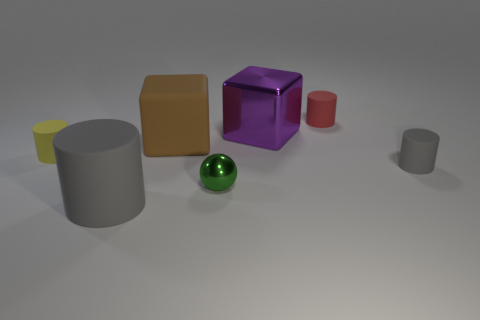Is the number of cylinders in front of the big purple block less than the number of things that are behind the small gray rubber cylinder?
Your response must be concise. Yes. There is a metallic thing that is in front of the gray object right of the large cylinder; what is its shape?
Offer a very short reply. Sphere. Are there any big balls?
Offer a very short reply. No. The metallic thing right of the green ball is what color?
Keep it short and to the point. Purple. What is the material of the other cylinder that is the same color as the large rubber cylinder?
Ensure brevity in your answer.  Rubber. Are there any red matte things on the right side of the tiny gray cylinder?
Keep it short and to the point. No. Are there more yellow cylinders than cyan blocks?
Keep it short and to the point. Yes. What color is the rubber thing on the right side of the small rubber cylinder that is behind the tiny rubber cylinder that is to the left of the metal sphere?
Provide a short and direct response. Gray. There is a block that is made of the same material as the big gray cylinder; what is its color?
Make the answer very short. Brown. Are there any other things that are the same size as the metallic block?
Provide a short and direct response. Yes. 